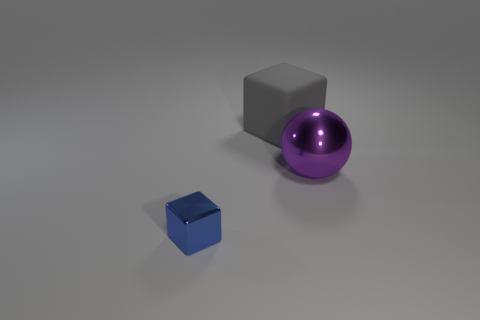Are there any big matte objects that are to the left of the block on the left side of the big matte block?
Keep it short and to the point. No. Are there any other shiny objects of the same shape as the blue shiny object?
Provide a short and direct response. No. Do the big ball and the tiny block have the same color?
Your response must be concise. No. There is a cube that is behind the large object in front of the gray thing; what is its material?
Make the answer very short. Rubber. What is the size of the gray matte block?
Ensure brevity in your answer.  Large. There is a cube that is made of the same material as the big ball; what size is it?
Your response must be concise. Small. There is a object in front of the purple object; is its size the same as the big gray object?
Give a very brief answer. No. There is a big thing on the left side of the metallic object that is on the right side of the small blue thing in front of the big purple shiny ball; what shape is it?
Provide a short and direct response. Cube. How many objects are large gray matte cubes or metallic objects that are right of the small blue metallic object?
Provide a short and direct response. 2. What is the size of the block to the right of the blue block?
Make the answer very short. Large. 